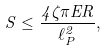<formula> <loc_0><loc_0><loc_500><loc_500>S \leq \frac { 4 \zeta \pi E R } { \ell _ { P } ^ { 2 } } ,</formula> 